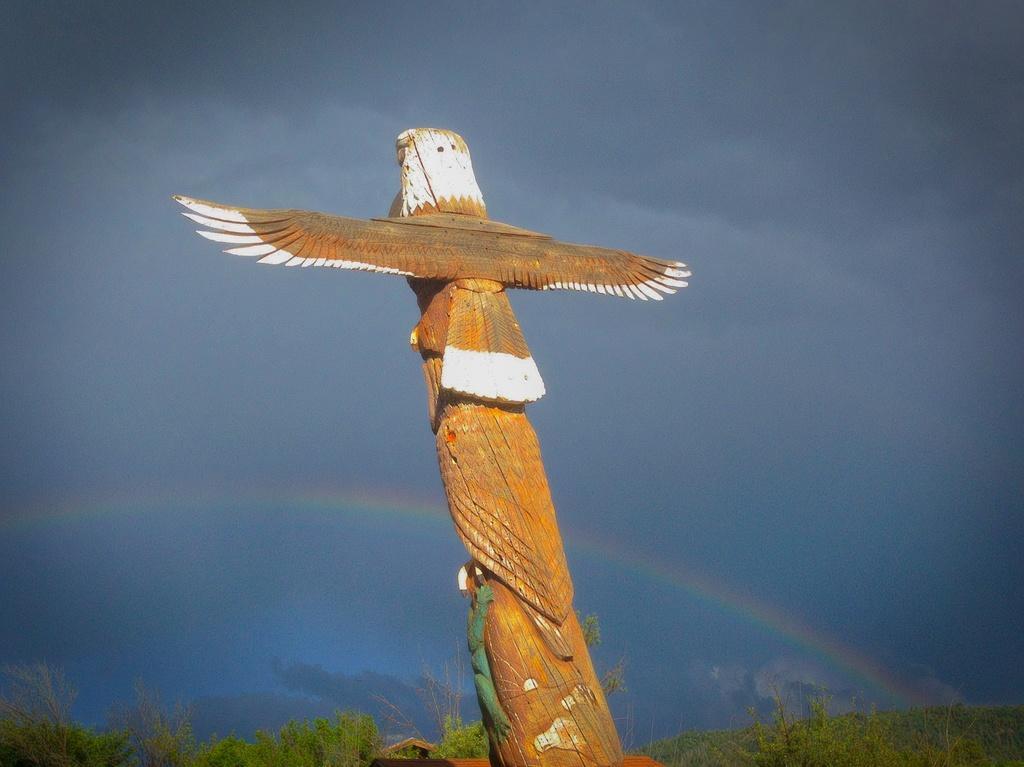In one or two sentences, can you explain what this image depicts? In this image in the center there is a wooden bird, and at the bottom there are some plants. And in the background there is rainbow, at the top there is sky. 